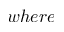<formula> <loc_0><loc_0><loc_500><loc_500>w h e r e</formula> 